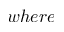<formula> <loc_0><loc_0><loc_500><loc_500>w h e r e</formula> 